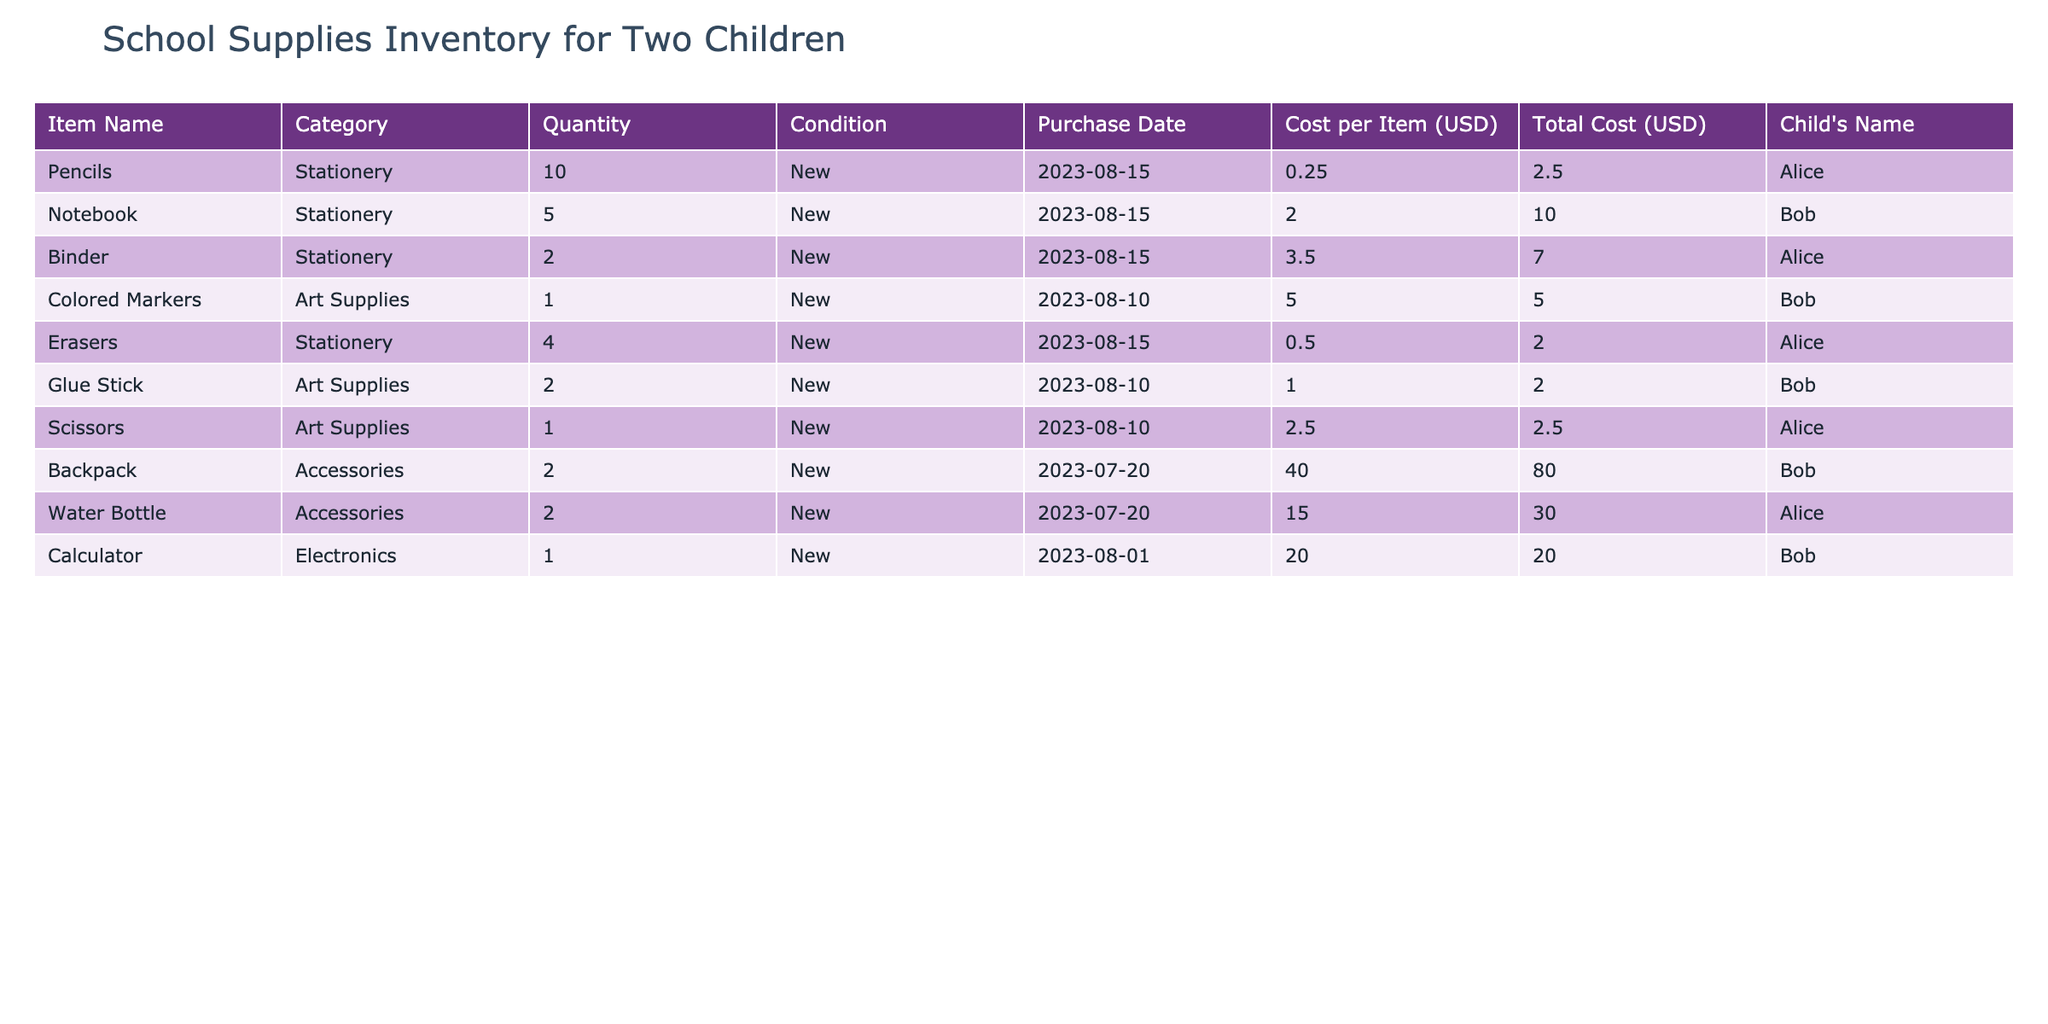What is the total quantity of art supplies for Alice? Alice has 1 pair of scissors and 0 colored markers, while Bob has 1 set of colored markers and 2 glue sticks, but only Alice's quantity is considered. Therefore, the total quantity for Alice is 1.
Answer: 1 How much did Bob spend on his school supplies? Bob’s school supplies include a notebook for 10.00, colored markers for 5.00, a glue stick for 2.00, a backpack for 80.00, a calculator for 20.00. Summing these amounts gives 10 + 5 + 2 + 80 + 20 = 117.00.
Answer: 117.00 Do both children have the same amount of stationery? Alice has 10 pencils, 2 binders, 4 erasers, totaling 16 items, while Bob has 5 notebooks, totaling 5 items. Since 16 is greater than 5, they do not have the same amount.
Answer: No What is the overall total cost of supplies for Alice and Bob combined? Alice's total cost is 2.50 (pencils) + 7.00 (binders) + 2.00 (erasers) + 2.50 (scissors) + 30.00 (water bottle) = 44.00. Bob's total cost is 10.00 (notebook) + 5.00 (colored markers) + 2.00 (glue stick) + 80.00 (backpack) + 20.00 (calculator) = 117.00. Adding both totals gives 44.00 + 117.00 = 161.00.
Answer: 161.00 How many items does Bob have in total? Bob has 5 notebooks, 1 set of colored markers, 2 glue sticks, 2 backpacks, and 1 calculator. Adding these quantities gives 5 + 1 + 2 + 2 + 1 = 11 items.
Answer: 11 